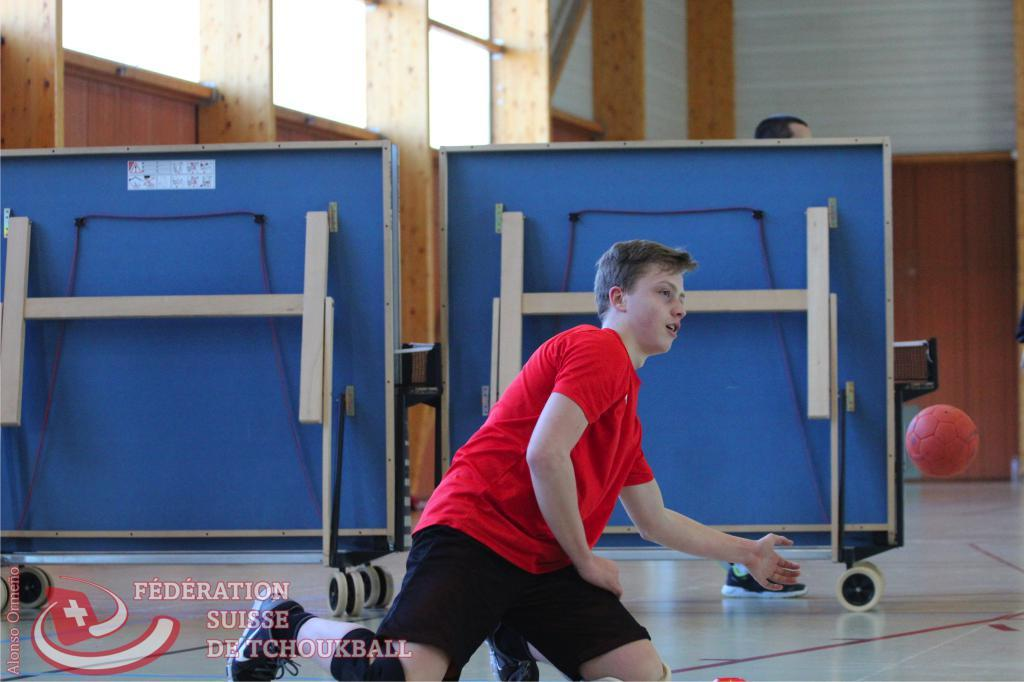<image>
Relay a brief, clear account of the picture shown. boy hitting red ball in front of blue folded up tables and in bottom left corner logo and words federation suisse de tchoukball 